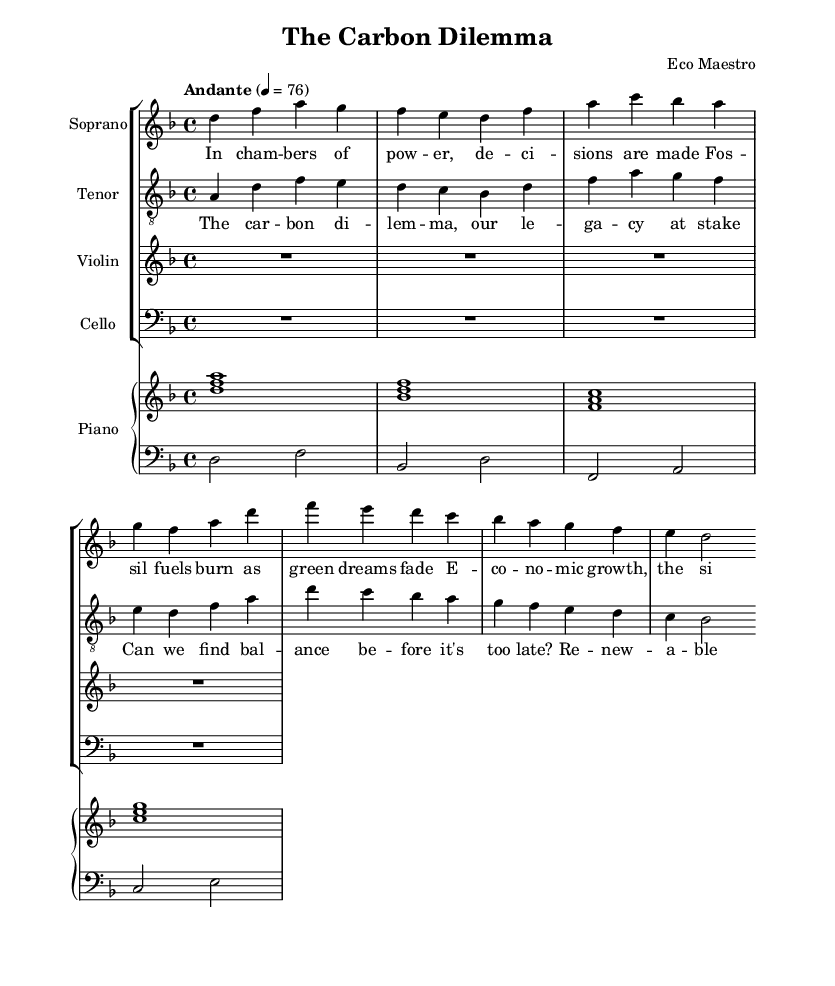What is the key signature of this music? The key signature is indicated at the beginning of the score with a "d" and a flat symbol, which means the music is in D minor.
Answer: D minor What is the time signature of this music? The time signature appears as "4/4" at the beginning of the score, indicating that there are four beats in a measure and the quarter note gets one beat.
Answer: 4/4 What is the tempo marking for this piece? The tempo is specified as "Andante" with a metronome marking of 76, suggesting a moderately slow tempo for the performance.
Answer: Andante, 76 How many measures are in the soprano part? By visually counting the notes and dividing them into measures in the soprano part, there are four measures present in total.
Answer: 4 Which two instruments play rests in the score? Looking at the notation, the Violin and Cello parts have rest symbols, indicating they are silent throughout the measures.
Answer: Violin, Cello What theme is introduced in the lyrics of the soprano? The lyrics describe "decisions are made" in power chambers, which emphasizes the conflicts between economic interests and environmental concerns, setting a thematic context for the opera.
Answer: Economic interests and environmental concerns 